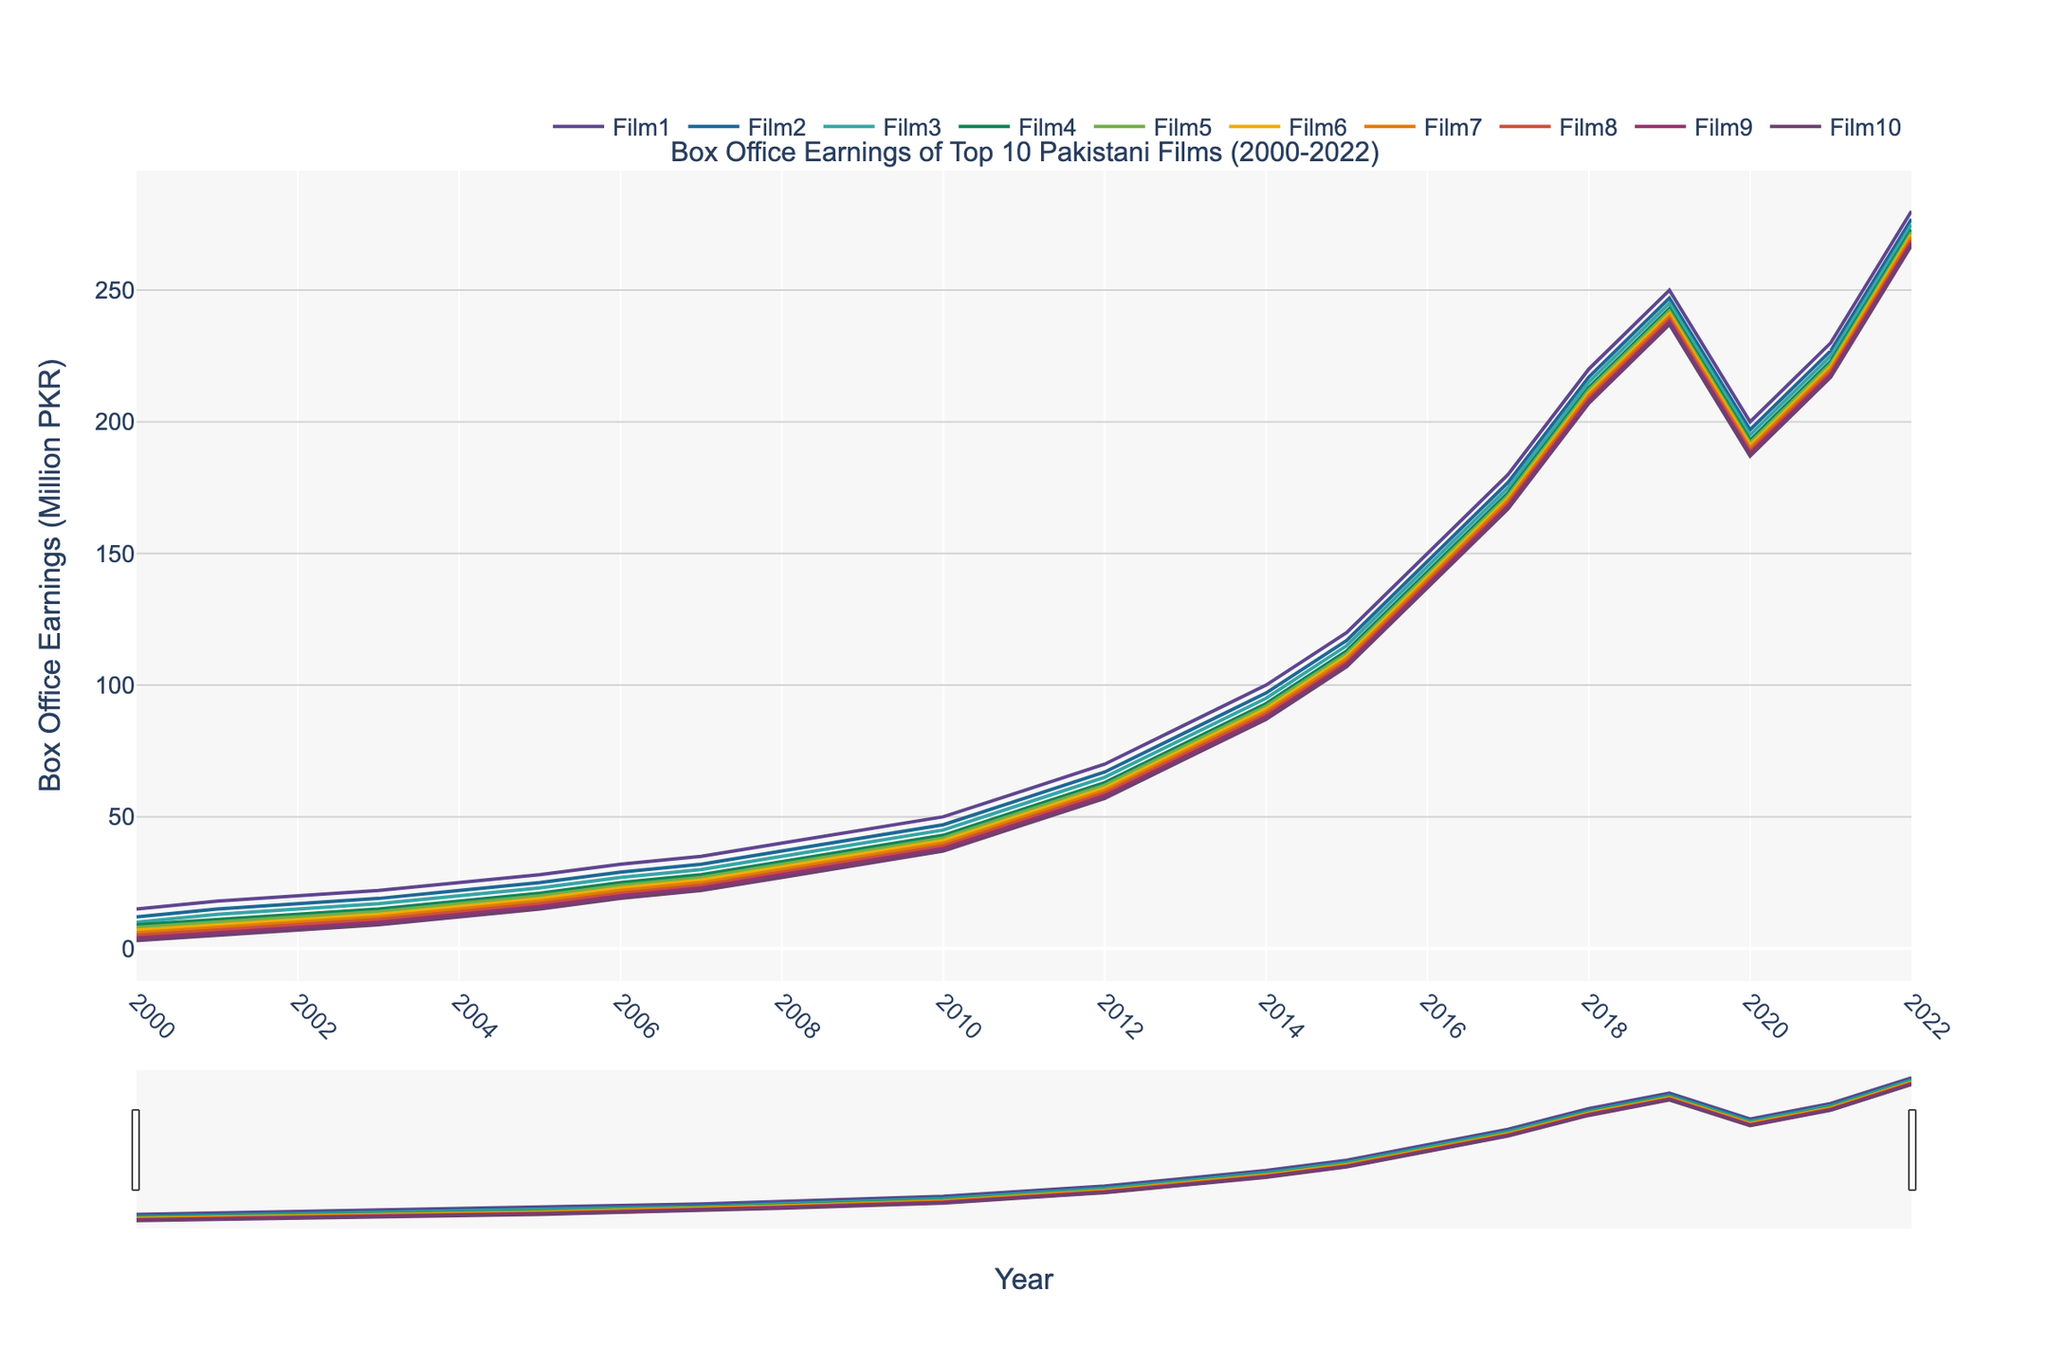What was the highest Box Office earning for any film in 2022? To answer this, look at the ending points of the lines on the graph for 2022. The highest earnings are from Film1, which is 280 million PKR.
Answer: 280 million PKR Which film had the most significant drop in Box Office earnings between 2019 and 2020? To find this, observe the slopes between 2019 and 2020. Calculate the drop for each film: Film1 (250 to 200), Film2 (247 to 197), and so on. The largest drop is in Film1, which dropped by 50 million PKR.
Answer: Film1 How many films crossed the 200 million PKR mark by 2022? Look at the ending points on the graph for 2022 and count the number of lines above 200 on the y-axis. Films 1 through 9 exceed 200 million PKR.
Answer: 9 films What was the average box office earnings of the top 3 films in 2016? Add the earnings of Film1 (150), Film2 (147), and Film3 (145), then divide by 3: (150 + 147 + 145) / 3 = 442 / 3 = 147.33 million PKR
Answer: 147.33 million PKR Which film performed better in 2018 compared to 2021? Compare the earnings from 2018 to 2021 for each film. Film1 (220 to 230), Film2 (217 to 227), ... Film10 (207 to 217). In all cases, every film performs better or remains consistent.
Answer: All films performed better What was the total Box Office earnings for Film10 from 2000 to 2022? Add the earnings for Film10 over all years: 3 + 5 + 7 + 9 + 12 + 15 + 19 + 22 + 27 + 32 + 37 + 47 + 57 + 72 + 87 + 107 + 137 + 167 + 207 + 187 + 217 + 267 = 1754 million PKR
Answer: 1754 million PKR What's the median earnings value for Film5 between 2005 and 2015? List the earnings for Film5 from 2005 to 2015: 20, 24, 27, 32, 37, 42, 52, 62, 77, 92, 112. The median of this set (ordered) is the middle number: 42.
Answer: 42 million PKR Which year showed the most significant overall increase in box office earnings for Film3? Look at the difference between consecutive years for Film3 and find the largest increase: from 2011 to 2012 (55 to 65) = 10 million PKR.
Answer: 2011-2012 What box office earnings were higher, Film7 in 2011 or Film9 in 2012? Look at the graph for Film7 in 2011 (50) and Film9 in 2012 (58).
Answer: Film9 in 2012 Which film showed a unique trend of decreasing earnings only in 2020? Identify the differences between 2019 and 2020 values for all films. All show a decrease, with all showing negative trends, except the recovery was more significant by Film1 (from 250 to 200). Due to COVID-19 in 2020
Answer: Film1 